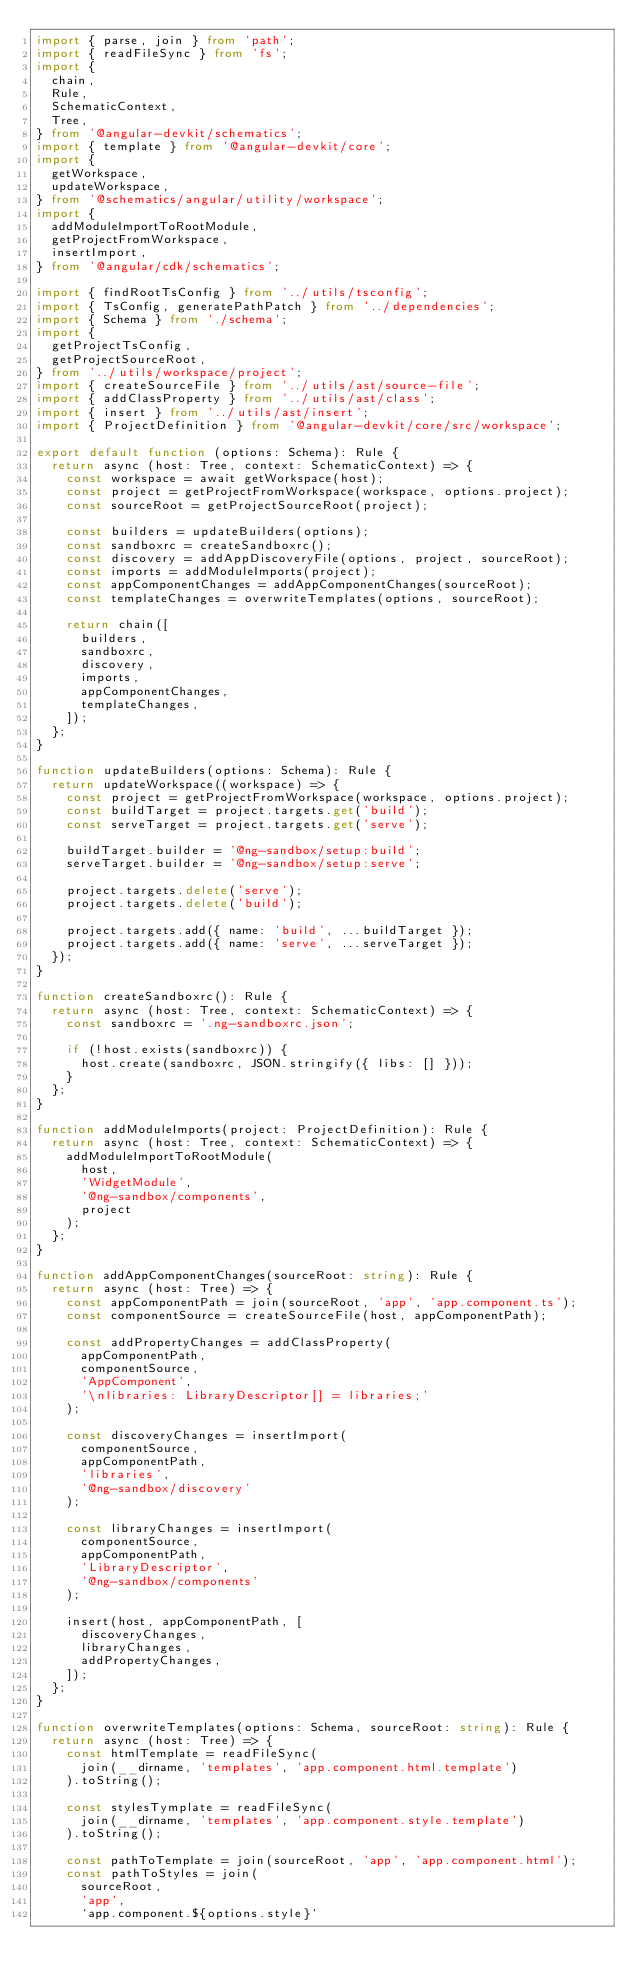<code> <loc_0><loc_0><loc_500><loc_500><_TypeScript_>import { parse, join } from 'path';
import { readFileSync } from 'fs';
import {
  chain,
  Rule,
  SchematicContext,
  Tree,
} from '@angular-devkit/schematics';
import { template } from '@angular-devkit/core';
import {
  getWorkspace,
  updateWorkspace,
} from '@schematics/angular/utility/workspace';
import {
  addModuleImportToRootModule,
  getProjectFromWorkspace,
  insertImport,
} from '@angular/cdk/schematics';

import { findRootTsConfig } from '../utils/tsconfig';
import { TsConfig, generatePathPatch } from '../dependencies';
import { Schema } from './schema';
import {
  getProjectTsConfig,
  getProjectSourceRoot,
} from '../utils/workspace/project';
import { createSourceFile } from '../utils/ast/source-file';
import { addClassProperty } from '../utils/ast/class';
import { insert } from '../utils/ast/insert';
import { ProjectDefinition } from '@angular-devkit/core/src/workspace';

export default function (options: Schema): Rule {
  return async (host: Tree, context: SchematicContext) => {
    const workspace = await getWorkspace(host);
    const project = getProjectFromWorkspace(workspace, options.project);
    const sourceRoot = getProjectSourceRoot(project);

    const builders = updateBuilders(options);
    const sandboxrc = createSandboxrc();
    const discovery = addAppDiscoveryFile(options, project, sourceRoot);
    const imports = addModuleImports(project);
    const appComponentChanges = addAppComponentChanges(sourceRoot);
    const templateChanges = overwriteTemplates(options, sourceRoot);

    return chain([
      builders,
      sandboxrc,
      discovery,
      imports,
      appComponentChanges,
      templateChanges,
    ]);
  };
}

function updateBuilders(options: Schema): Rule {
  return updateWorkspace((workspace) => {
    const project = getProjectFromWorkspace(workspace, options.project);
    const buildTarget = project.targets.get('build');
    const serveTarget = project.targets.get('serve');

    buildTarget.builder = '@ng-sandbox/setup:build';
    serveTarget.builder = '@ng-sandbox/setup:serve';

    project.targets.delete('serve');
    project.targets.delete('build');

    project.targets.add({ name: 'build', ...buildTarget });
    project.targets.add({ name: 'serve', ...serveTarget });
  });
}

function createSandboxrc(): Rule {
  return async (host: Tree, context: SchematicContext) => {
    const sandboxrc = '.ng-sandboxrc.json';

    if (!host.exists(sandboxrc)) {
      host.create(sandboxrc, JSON.stringify({ libs: [] }));
    }
  };
}

function addModuleImports(project: ProjectDefinition): Rule {
  return async (host: Tree, context: SchematicContext) => {
    addModuleImportToRootModule(
      host,
      'WidgetModule',
      '@ng-sandbox/components',
      project
    );
  };
}

function addAppComponentChanges(sourceRoot: string): Rule {
  return async (host: Tree) => {
    const appComponentPath = join(sourceRoot, 'app', 'app.component.ts');
    const componentSource = createSourceFile(host, appComponentPath);

    const addPropertyChanges = addClassProperty(
      appComponentPath,
      componentSource,
      'AppComponent',
      '\nlibraries: LibraryDescriptor[] = libraries;'
    );

    const discoveryChanges = insertImport(
      componentSource,
      appComponentPath,
      'libraries',
      '@ng-sandbox/discovery'
    );

    const libraryChanges = insertImport(
      componentSource,
      appComponentPath,
      'LibraryDescriptor',
      '@ng-sandbox/components'
    );

    insert(host, appComponentPath, [
      discoveryChanges,
      libraryChanges,
      addPropertyChanges,
    ]);
  };
}

function overwriteTemplates(options: Schema, sourceRoot: string): Rule {
  return async (host: Tree) => {
    const htmlTemplate = readFileSync(
      join(__dirname, 'templates', 'app.component.html.template')
    ).toString();

    const stylesTymplate = readFileSync(
      join(__dirname, 'templates', 'app.component.style.template')
    ).toString();

    const pathToTemplate = join(sourceRoot, 'app', 'app.component.html');
    const pathToStyles = join(
      sourceRoot,
      'app',
      `app.component.${options.style}`</code> 